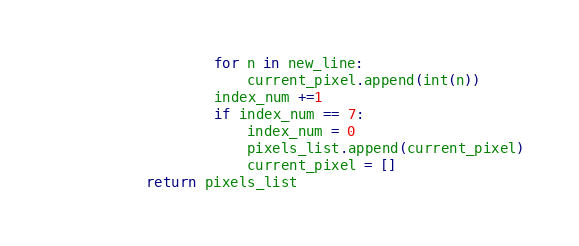<code> <loc_0><loc_0><loc_500><loc_500><_Python_>                for n in new_line:
                    current_pixel.append(int(n))
                index_num +=1
                if index_num == 7:
                    index_num = 0
                    pixels_list.append(current_pixel)
                    current_pixel = []
        return pixels_list
</code> 